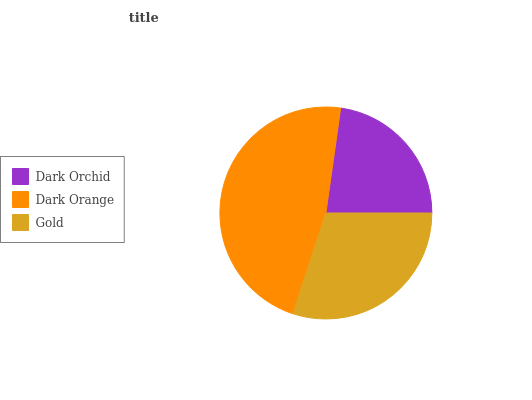Is Dark Orchid the minimum?
Answer yes or no. Yes. Is Dark Orange the maximum?
Answer yes or no. Yes. Is Gold the minimum?
Answer yes or no. No. Is Gold the maximum?
Answer yes or no. No. Is Dark Orange greater than Gold?
Answer yes or no. Yes. Is Gold less than Dark Orange?
Answer yes or no. Yes. Is Gold greater than Dark Orange?
Answer yes or no. No. Is Dark Orange less than Gold?
Answer yes or no. No. Is Gold the high median?
Answer yes or no. Yes. Is Gold the low median?
Answer yes or no. Yes. Is Dark Orchid the high median?
Answer yes or no. No. Is Dark Orchid the low median?
Answer yes or no. No. 